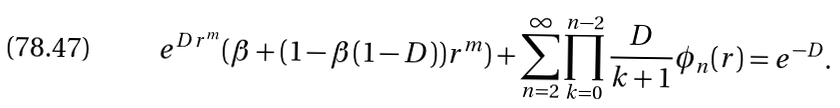<formula> <loc_0><loc_0><loc_500><loc_500>e ^ { D r ^ { m } } ( \beta + ( 1 - \beta ( 1 - D ) ) r ^ { m } ) + \sum _ { n = 2 } ^ { \infty } \prod _ { k = 0 } ^ { n - 2 } \frac { D } { k + 1 } \phi _ { n } ( r ) = e ^ { - D } .</formula> 